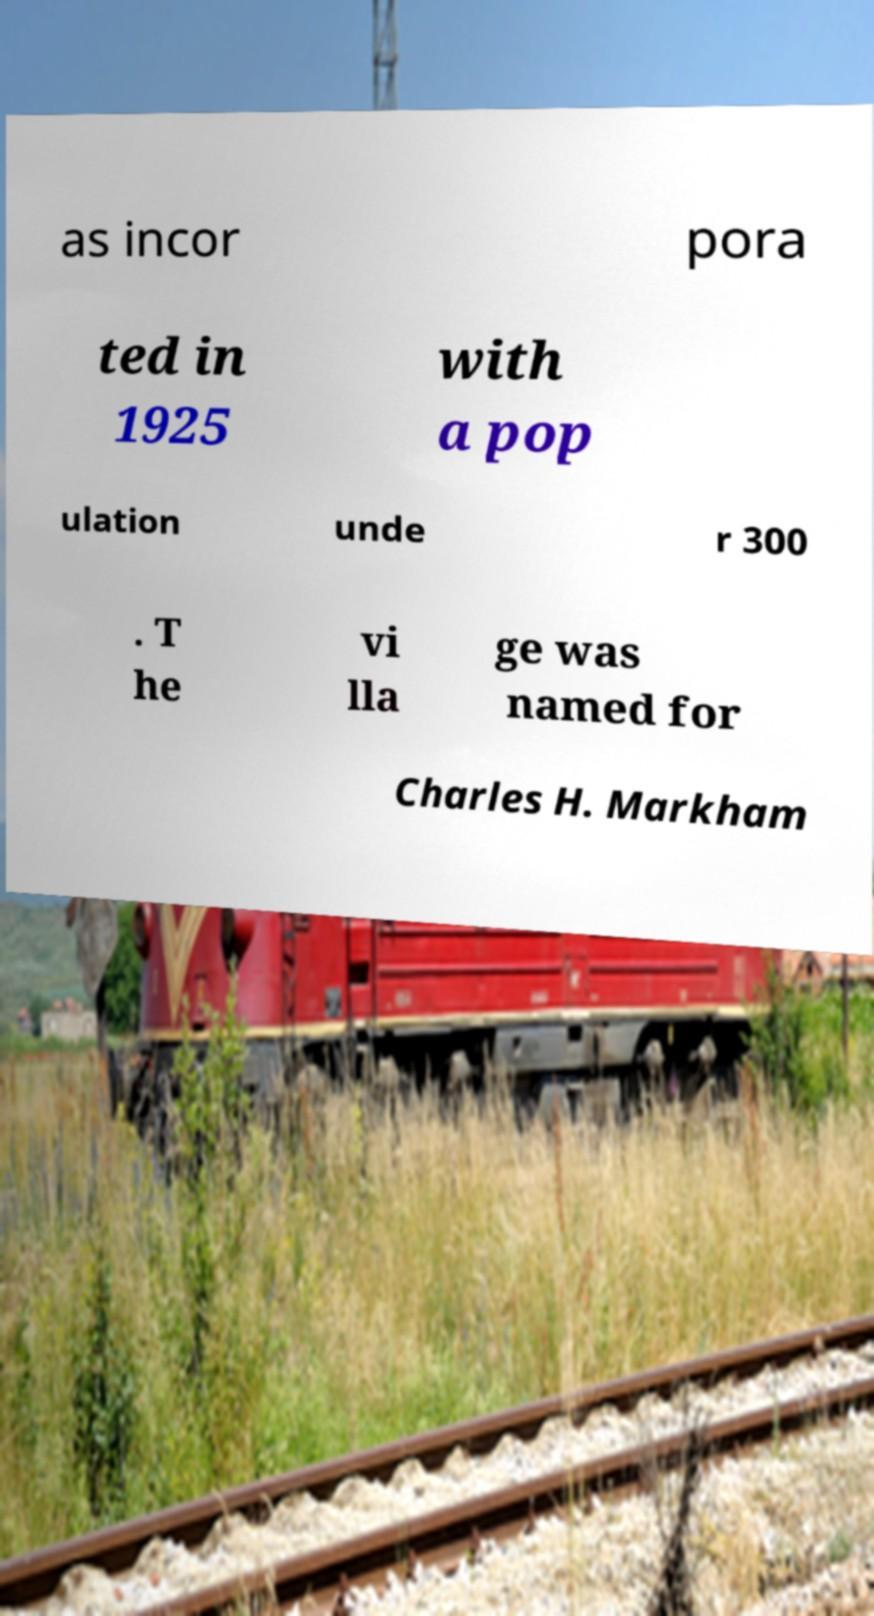Please read and relay the text visible in this image. What does it say? as incor pora ted in 1925 with a pop ulation unde r 300 . T he vi lla ge was named for Charles H. Markham 